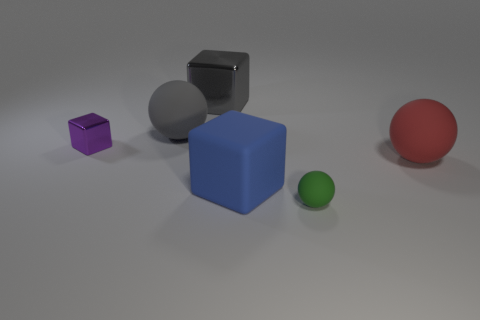Subtract all big balls. How many balls are left? 1 Add 4 large purple metal things. How many objects exist? 10 Add 4 cubes. How many cubes are left? 7 Add 5 large red spheres. How many large red spheres exist? 6 Subtract 0 red blocks. How many objects are left? 6 Subtract all green matte objects. Subtract all purple metal things. How many objects are left? 4 